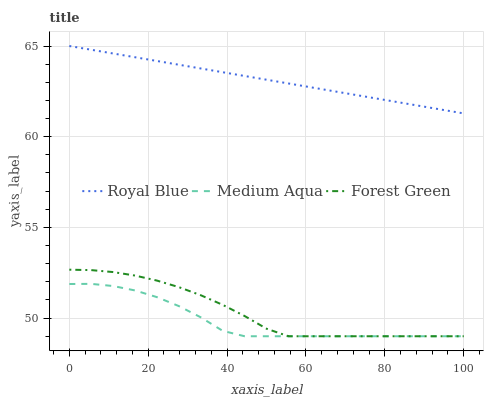Does Medium Aqua have the minimum area under the curve?
Answer yes or no. Yes. Does Royal Blue have the maximum area under the curve?
Answer yes or no. Yes. Does Forest Green have the minimum area under the curve?
Answer yes or no. No. Does Forest Green have the maximum area under the curve?
Answer yes or no. No. Is Royal Blue the smoothest?
Answer yes or no. Yes. Is Medium Aqua the roughest?
Answer yes or no. Yes. Is Forest Green the smoothest?
Answer yes or no. No. Is Forest Green the roughest?
Answer yes or no. No. Does Royal Blue have the highest value?
Answer yes or no. Yes. Does Forest Green have the highest value?
Answer yes or no. No. Is Medium Aqua less than Royal Blue?
Answer yes or no. Yes. Is Royal Blue greater than Forest Green?
Answer yes or no. Yes. Does Forest Green intersect Medium Aqua?
Answer yes or no. Yes. Is Forest Green less than Medium Aqua?
Answer yes or no. No. Is Forest Green greater than Medium Aqua?
Answer yes or no. No. Does Medium Aqua intersect Royal Blue?
Answer yes or no. No. 